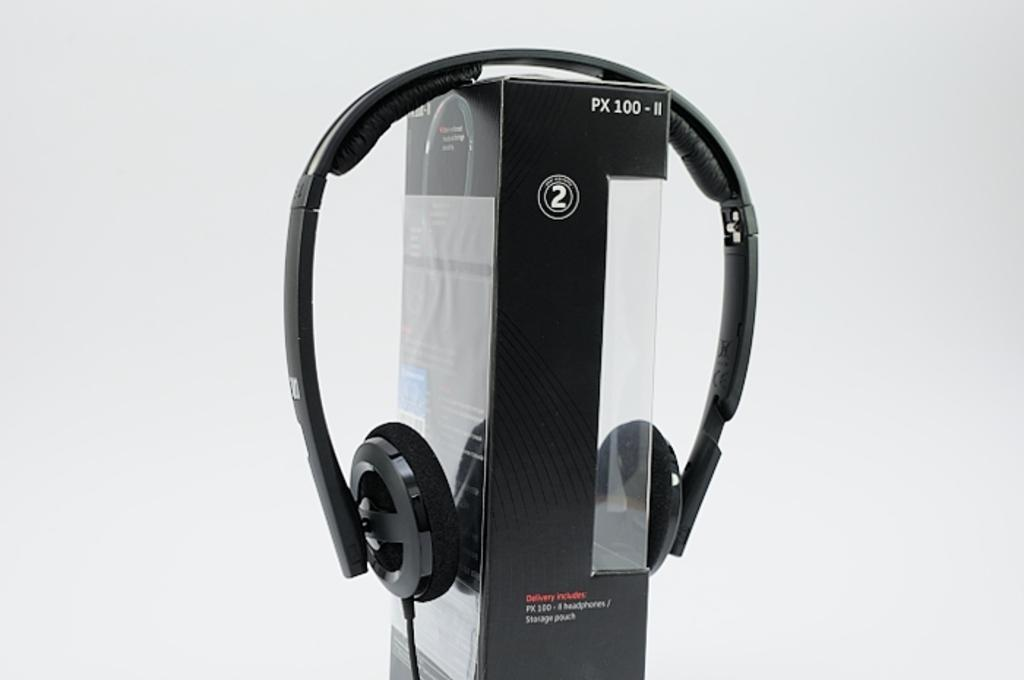What type of audio accessory is present in the image? There are headphones in the image. What other object can be seen in the image? There is a box in the image. What color are the headphones and the box? Both the headphones and the box are black in color. How does the parent interact with the headphones in the image? There is no parent present in the image, so it is not possible to determine how they might interact with the headphones. 